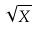<formula> <loc_0><loc_0><loc_500><loc_500>\sqrt { X }</formula> 